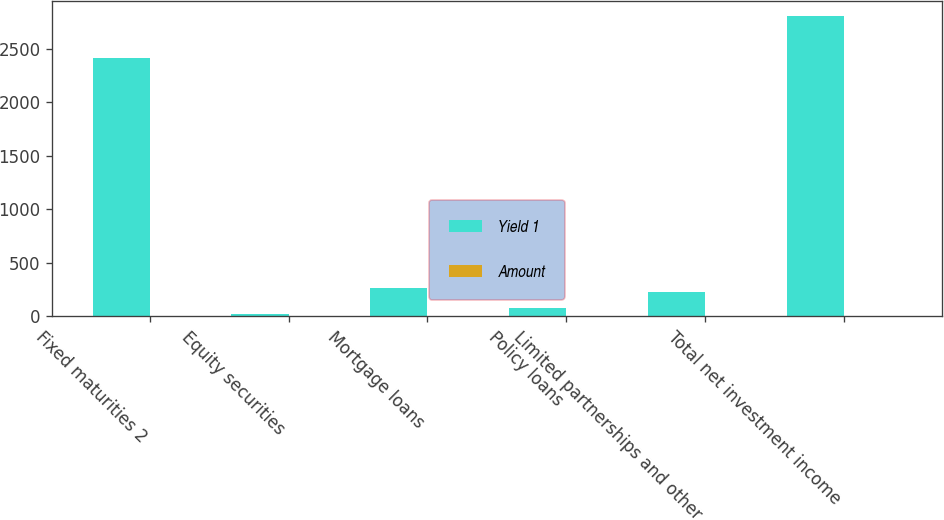<chart> <loc_0><loc_0><loc_500><loc_500><stacked_bar_chart><ecel><fcel>Fixed maturities 2<fcel>Equity securities<fcel>Mortgage loans<fcel>Policy loans<fcel>Limited partnerships and other<fcel>Total net investment income<nl><fcel>Yield 1<fcel>2409<fcel>25<fcel>267<fcel>82<fcel>227<fcel>2803<nl><fcel>Amount<fcel>4.2<fcel>2.4<fcel>4.7<fcel>5.7<fcel>8<fcel>4.1<nl></chart> 